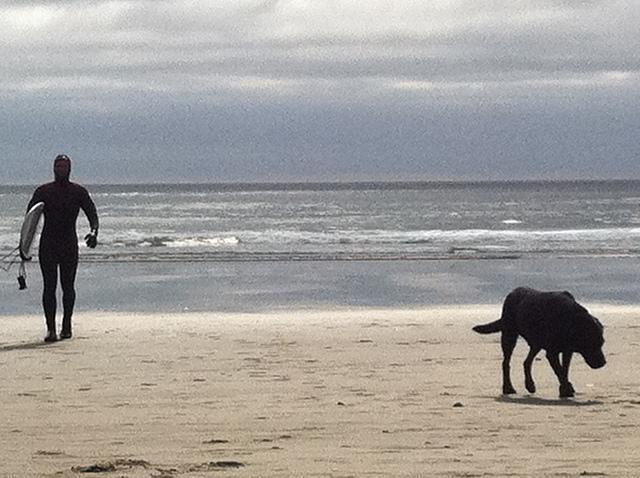How many people are in the photo?
Give a very brief answer. 1. How many trains have lights on?
Give a very brief answer. 0. 